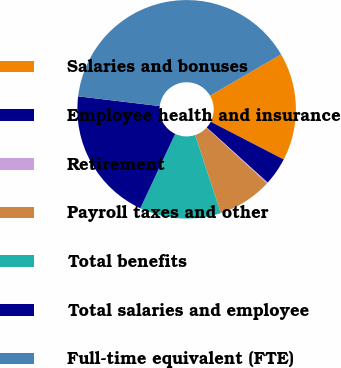<chart> <loc_0><loc_0><loc_500><loc_500><pie_chart><fcel>Salaries and bonuses<fcel>Employee health and insurance<fcel>Retirement<fcel>Payroll taxes and other<fcel>Total benefits<fcel>Total salaries and employee<fcel>Full-time equivalent (FTE)<nl><fcel>15.98%<fcel>4.11%<fcel>0.16%<fcel>8.07%<fcel>12.03%<fcel>19.94%<fcel>39.72%<nl></chart> 